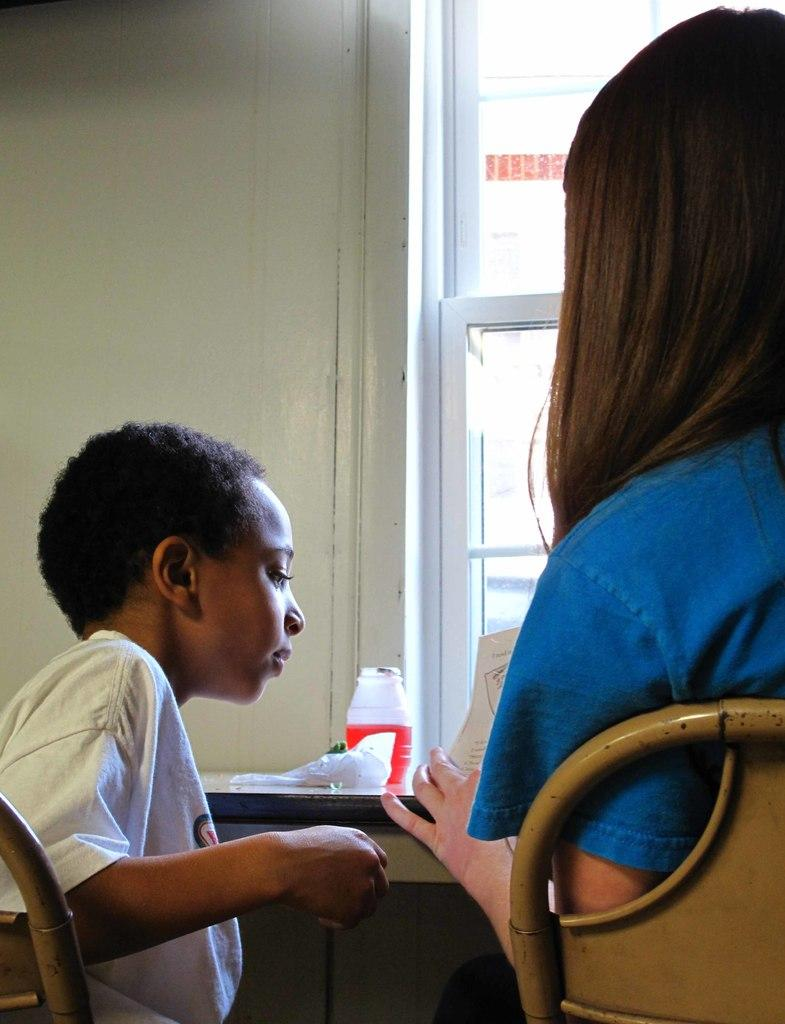Who is the main subject in the image? There is a woman in the image. What is the woman wearing? The woman is wearing a blue shirt. What is the woman doing in the image? The woman is sitting in a chair and holding a paper. What is the woman's proximity to a table in the image? The woman is in front of a table. Who else is present in the image? There is a kid sitting beside the woman. What type of cast is visible on the woman's arm in the image? There is no cast visible on the woman's arm in the image. What question is the woman asking the kid in the image? The image does not show the woman asking any questions, so we cannot determine what question she might be asking. 